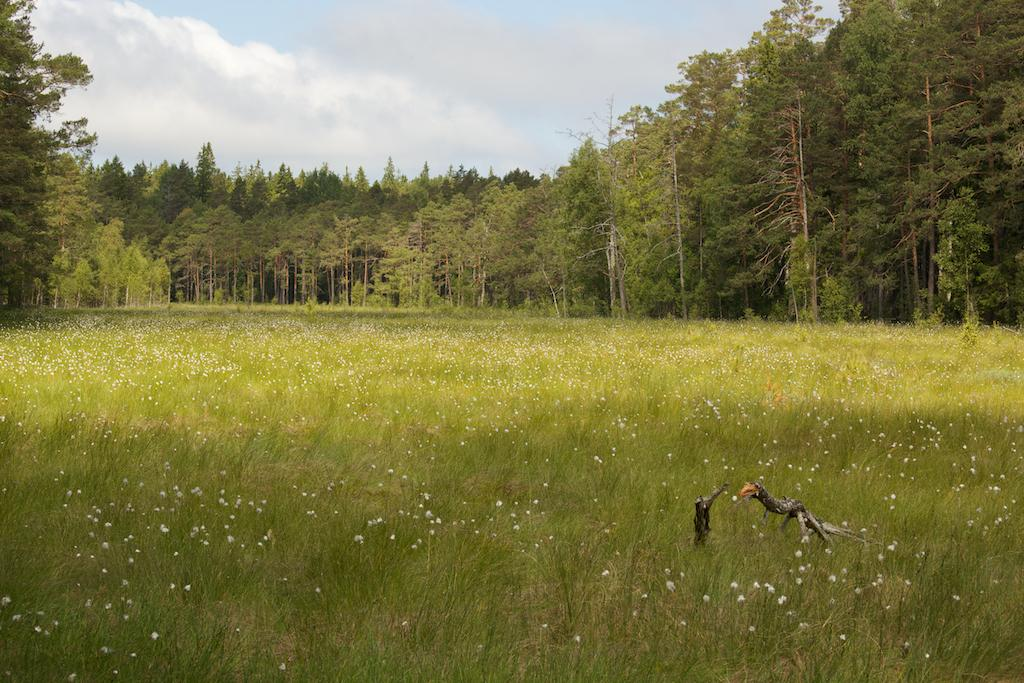What type of vegetation is visible in the front of the image? There are plants in the front of the image. What animals can be seen in the image? It appears there are birds in the image. What type of vegetation is visible in the background of the image? There are trees in the background of the image. How would you describe the sky in the image? The sky is cloudy in the background of the image. What type of sack is being used for the discussion in the image? There is no sack or discussion present in the image. How many snails can be seen interacting with the plants in the image? There are no snails visible in the image; only plants and birds are present. 